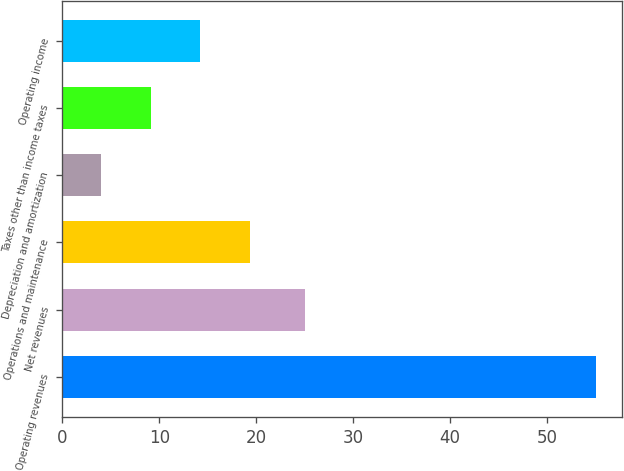Convert chart to OTSL. <chart><loc_0><loc_0><loc_500><loc_500><bar_chart><fcel>Operating revenues<fcel>Net revenues<fcel>Operations and maintenance<fcel>Depreciation and amortization<fcel>Taxes other than income taxes<fcel>Operating income<nl><fcel>55<fcel>25<fcel>19.3<fcel>4<fcel>9.1<fcel>14.2<nl></chart> 